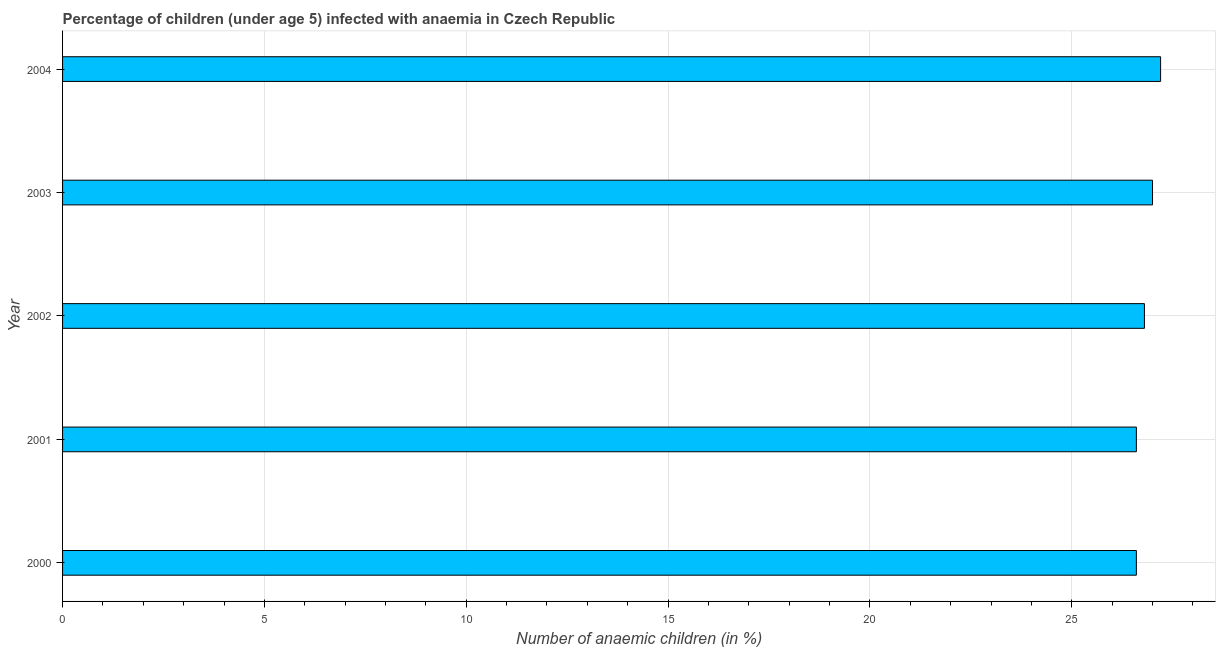Does the graph contain any zero values?
Your response must be concise. No. Does the graph contain grids?
Provide a succinct answer. Yes. What is the title of the graph?
Ensure brevity in your answer.  Percentage of children (under age 5) infected with anaemia in Czech Republic. What is the label or title of the X-axis?
Provide a succinct answer. Number of anaemic children (in %). What is the label or title of the Y-axis?
Keep it short and to the point. Year. What is the number of anaemic children in 2004?
Your answer should be compact. 27.2. Across all years, what is the maximum number of anaemic children?
Provide a short and direct response. 27.2. Across all years, what is the minimum number of anaemic children?
Offer a terse response. 26.6. In which year was the number of anaemic children maximum?
Keep it short and to the point. 2004. What is the sum of the number of anaemic children?
Your answer should be very brief. 134.2. What is the difference between the number of anaemic children in 2001 and 2003?
Ensure brevity in your answer.  -0.4. What is the average number of anaemic children per year?
Provide a succinct answer. 26.84. What is the median number of anaemic children?
Your answer should be very brief. 26.8. Is the number of anaemic children in 2000 less than that in 2002?
Your answer should be compact. Yes. Is the difference between the number of anaemic children in 2000 and 2001 greater than the difference between any two years?
Your response must be concise. No. What is the difference between the highest and the second highest number of anaemic children?
Keep it short and to the point. 0.2. Is the sum of the number of anaemic children in 2000 and 2002 greater than the maximum number of anaemic children across all years?
Your response must be concise. Yes. What is the difference between the highest and the lowest number of anaemic children?
Your response must be concise. 0.6. In how many years, is the number of anaemic children greater than the average number of anaemic children taken over all years?
Your answer should be compact. 2. What is the difference between two consecutive major ticks on the X-axis?
Offer a terse response. 5. Are the values on the major ticks of X-axis written in scientific E-notation?
Make the answer very short. No. What is the Number of anaemic children (in %) in 2000?
Provide a short and direct response. 26.6. What is the Number of anaemic children (in %) of 2001?
Your answer should be compact. 26.6. What is the Number of anaemic children (in %) of 2002?
Your answer should be compact. 26.8. What is the Number of anaemic children (in %) in 2004?
Offer a terse response. 27.2. What is the difference between the Number of anaemic children (in %) in 2000 and 2001?
Your answer should be compact. 0. What is the difference between the Number of anaemic children (in %) in 2001 and 2002?
Your response must be concise. -0.2. What is the difference between the Number of anaemic children (in %) in 2001 and 2004?
Your answer should be very brief. -0.6. What is the ratio of the Number of anaemic children (in %) in 2000 to that in 2002?
Ensure brevity in your answer.  0.99. What is the ratio of the Number of anaemic children (in %) in 2000 to that in 2003?
Keep it short and to the point. 0.98. What is the ratio of the Number of anaemic children (in %) in 2000 to that in 2004?
Your answer should be very brief. 0.98. What is the ratio of the Number of anaemic children (in %) in 2001 to that in 2002?
Your answer should be very brief. 0.99. What is the ratio of the Number of anaemic children (in %) in 2001 to that in 2004?
Make the answer very short. 0.98. What is the ratio of the Number of anaemic children (in %) in 2002 to that in 2004?
Your response must be concise. 0.98. What is the ratio of the Number of anaemic children (in %) in 2003 to that in 2004?
Your response must be concise. 0.99. 